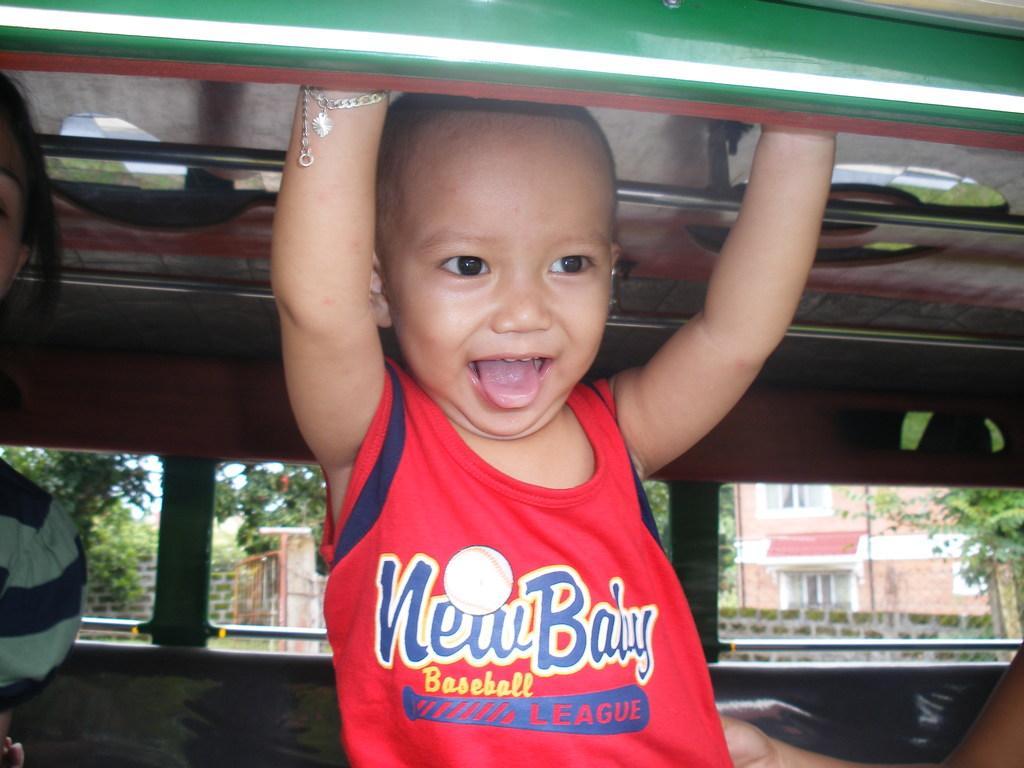Could you give a brief overview of what you see in this image? In this image there is a kid on a bus looking through the window, beside the kid there is a person, behind the kid there are windows of a person, from the windows we can see trees and houses. 